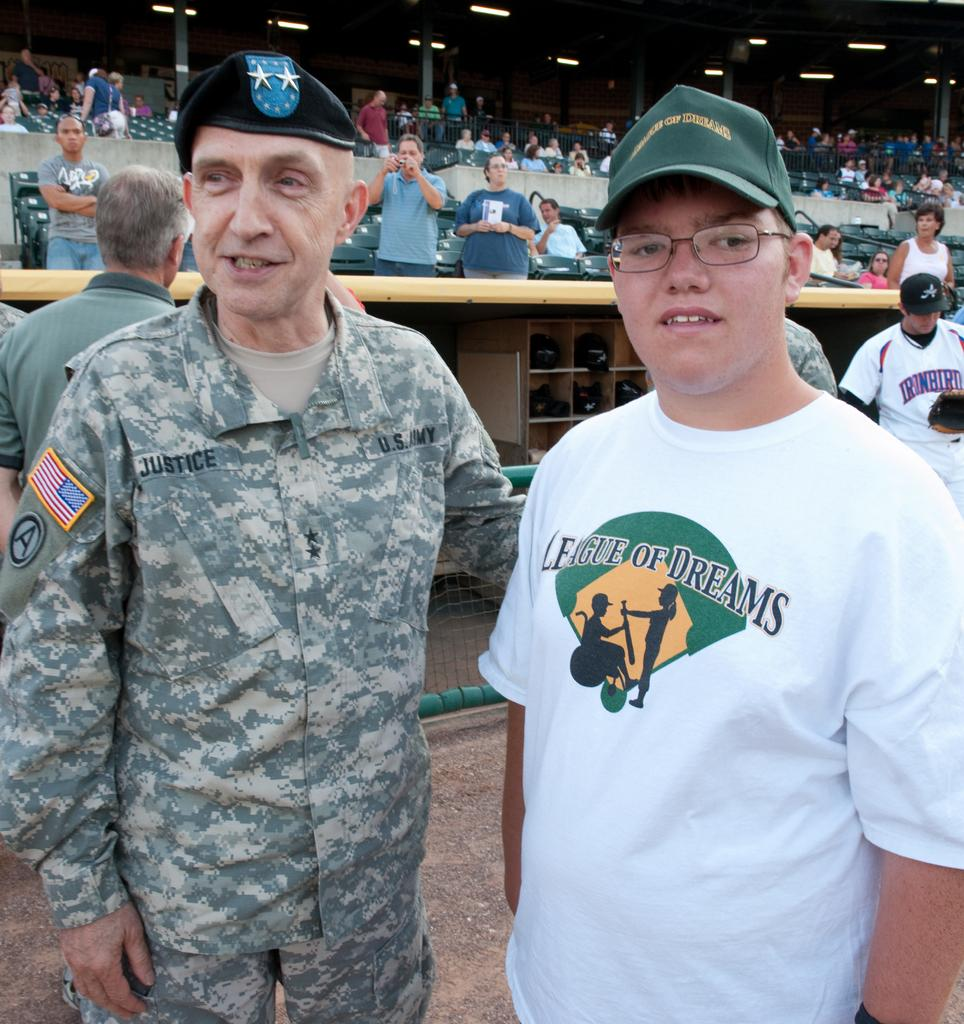<image>
Write a terse but informative summary of the picture. A man in US Army uniform stands with a boy in front of a baseball dugout. 